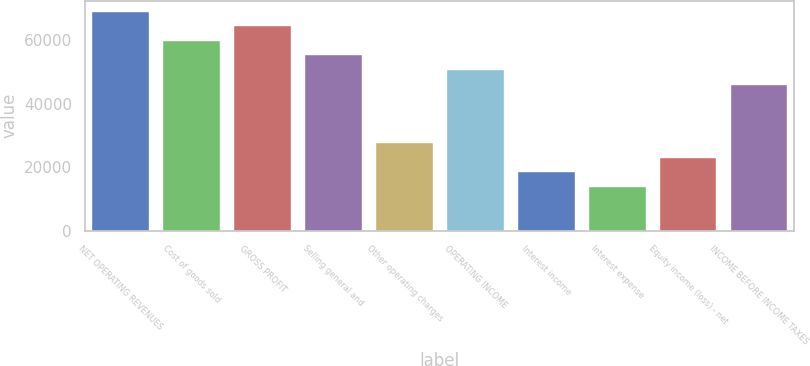Convert chart. <chart><loc_0><loc_0><loc_500><loc_500><bar_chart><fcel>NET OPERATING REVENUES<fcel>Cost of goods sold<fcel>GROSS PROFIT<fcel>Selling general and<fcel>Other operating charges<fcel>OPERATING INCOME<fcel>Interest income<fcel>Interest expense<fcel>Equity income (loss) - net<fcel>INCOME BEFORE INCOME TAXES<nl><fcel>68996.2<fcel>59796.9<fcel>64396.6<fcel>55197.3<fcel>27599.4<fcel>50597.6<fcel>18400.2<fcel>13800.5<fcel>22999.8<fcel>45998<nl></chart> 